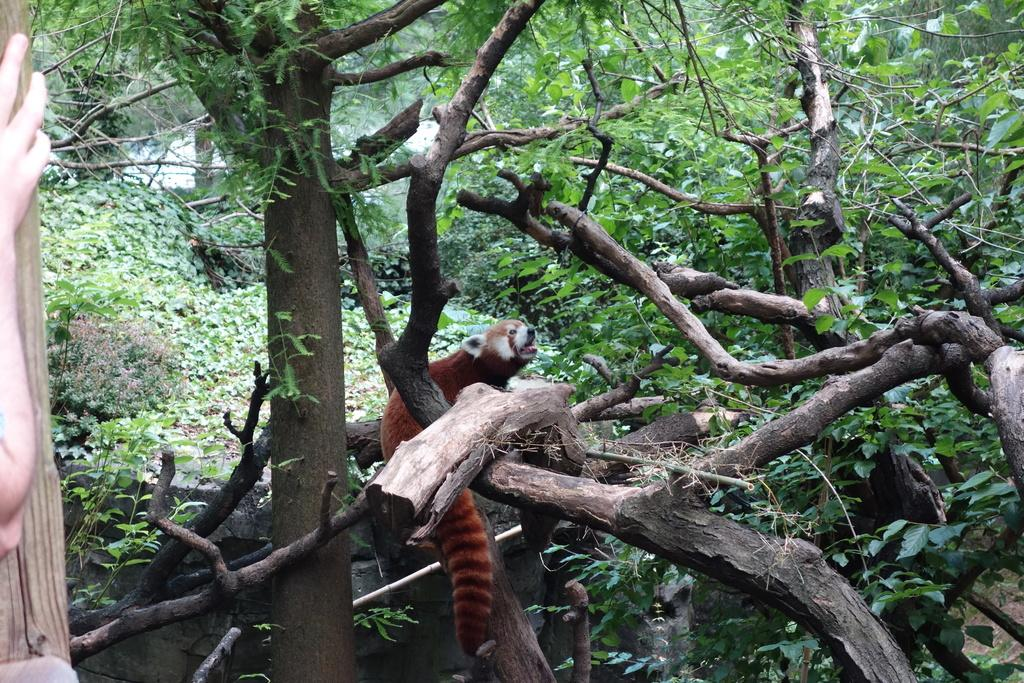What type of natural elements are present in the image? There are trees and plants in the image. What is the main subject in the middle of the image? There is an animal in the middle of the image. Can you describe the presence of a human element in the image? There is a person's hand on the left side of the image. How many planes can be seen flying over the animal in the image? There are no planes visible in the image; it only features trees, plants, an animal, and a person's hand. What is the amount of dog food needed for the animal in the image? There is no information about the animal's diet or the presence of dog food in the image. 